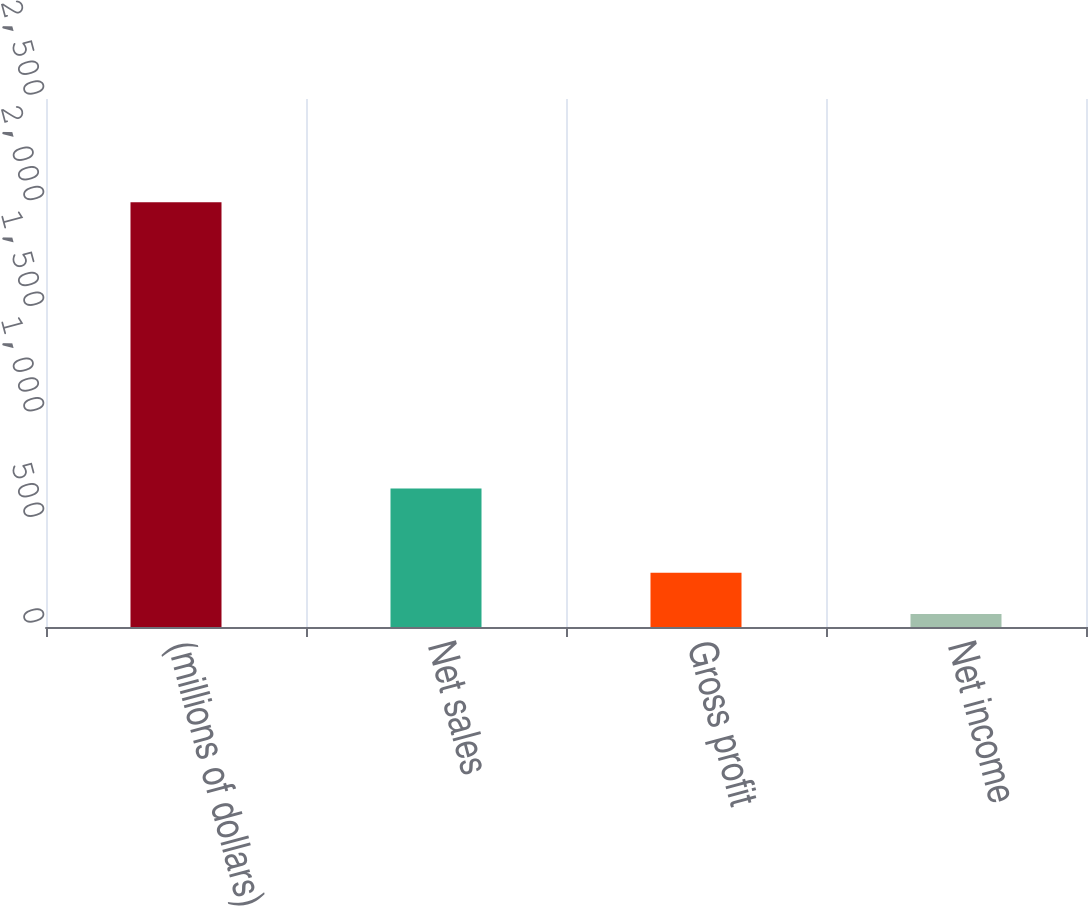Convert chart. <chart><loc_0><loc_0><loc_500><loc_500><bar_chart><fcel>(millions of dollars)<fcel>Net sales<fcel>Gross profit<fcel>Net income<nl><fcel>2011<fcel>655.2<fcel>256.54<fcel>61.6<nl></chart> 